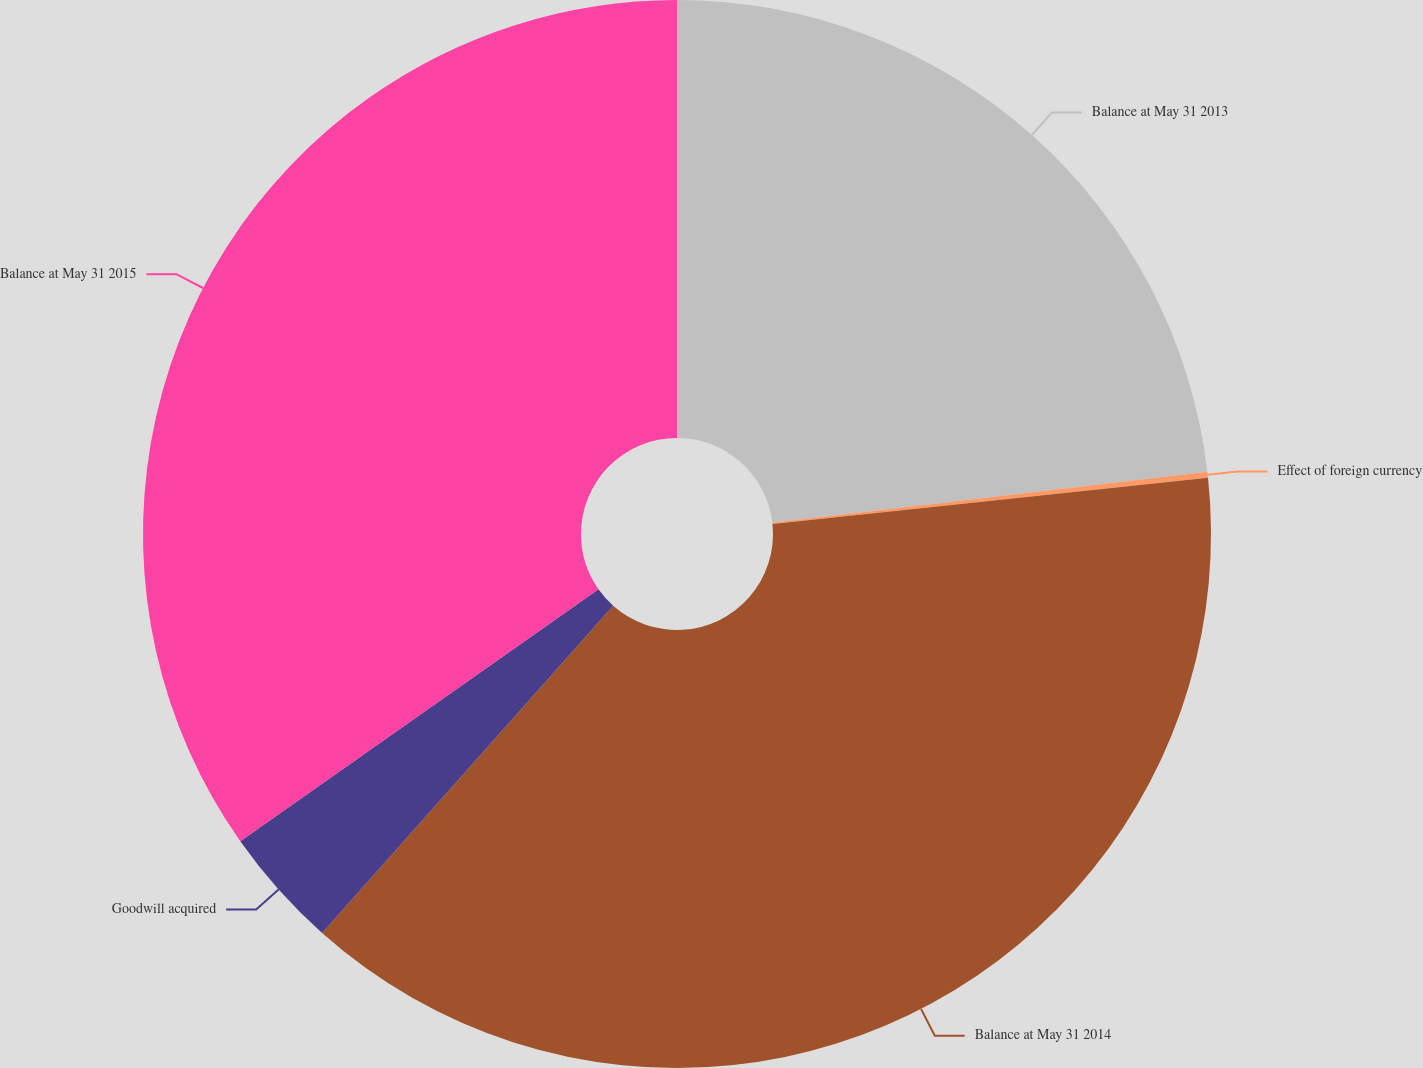Convert chart. <chart><loc_0><loc_0><loc_500><loc_500><pie_chart><fcel>Balance at May 31 2013<fcel>Effect of foreign currency<fcel>Balance at May 31 2014<fcel>Goodwill acquired<fcel>Balance at May 31 2015<nl><fcel>23.14%<fcel>0.18%<fcel>38.25%<fcel>3.67%<fcel>34.76%<nl></chart> 